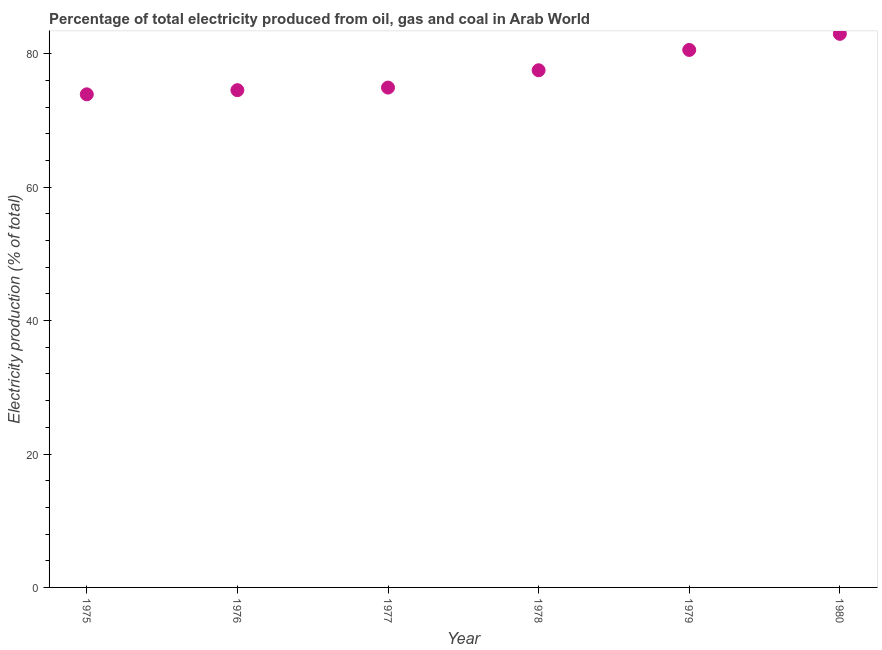What is the electricity production in 1977?
Keep it short and to the point. 74.94. Across all years, what is the maximum electricity production?
Offer a terse response. 82.99. Across all years, what is the minimum electricity production?
Your response must be concise. 73.92. In which year was the electricity production maximum?
Make the answer very short. 1980. In which year was the electricity production minimum?
Your answer should be compact. 1975. What is the sum of the electricity production?
Your answer should be very brief. 464.52. What is the difference between the electricity production in 1978 and 1980?
Offer a terse response. -5.46. What is the average electricity production per year?
Your response must be concise. 77.42. What is the median electricity production?
Make the answer very short. 76.24. Do a majority of the years between 1975 and 1979 (inclusive) have electricity production greater than 64 %?
Your answer should be compact. Yes. What is the ratio of the electricity production in 1978 to that in 1980?
Your answer should be compact. 0.93. Is the difference between the electricity production in 1975 and 1978 greater than the difference between any two years?
Your response must be concise. No. What is the difference between the highest and the second highest electricity production?
Your answer should be compact. 2.41. What is the difference between the highest and the lowest electricity production?
Your answer should be compact. 9.07. How many dotlines are there?
Keep it short and to the point. 1. How many years are there in the graph?
Ensure brevity in your answer.  6. Are the values on the major ticks of Y-axis written in scientific E-notation?
Offer a very short reply. No. Does the graph contain any zero values?
Offer a very short reply. No. What is the title of the graph?
Keep it short and to the point. Percentage of total electricity produced from oil, gas and coal in Arab World. What is the label or title of the X-axis?
Offer a terse response. Year. What is the label or title of the Y-axis?
Offer a very short reply. Electricity production (% of total). What is the Electricity production (% of total) in 1975?
Provide a short and direct response. 73.92. What is the Electricity production (% of total) in 1976?
Provide a succinct answer. 74.55. What is the Electricity production (% of total) in 1977?
Your response must be concise. 74.94. What is the Electricity production (% of total) in 1978?
Keep it short and to the point. 77.53. What is the Electricity production (% of total) in 1979?
Make the answer very short. 80.58. What is the Electricity production (% of total) in 1980?
Your answer should be very brief. 82.99. What is the difference between the Electricity production (% of total) in 1975 and 1976?
Give a very brief answer. -0.62. What is the difference between the Electricity production (% of total) in 1975 and 1977?
Give a very brief answer. -1.01. What is the difference between the Electricity production (% of total) in 1975 and 1978?
Offer a very short reply. -3.61. What is the difference between the Electricity production (% of total) in 1975 and 1979?
Provide a succinct answer. -6.66. What is the difference between the Electricity production (% of total) in 1975 and 1980?
Offer a terse response. -9.07. What is the difference between the Electricity production (% of total) in 1976 and 1977?
Offer a terse response. -0.39. What is the difference between the Electricity production (% of total) in 1976 and 1978?
Provide a succinct answer. -2.99. What is the difference between the Electricity production (% of total) in 1976 and 1979?
Ensure brevity in your answer.  -6.03. What is the difference between the Electricity production (% of total) in 1976 and 1980?
Offer a terse response. -8.44. What is the difference between the Electricity production (% of total) in 1977 and 1978?
Offer a very short reply. -2.6. What is the difference between the Electricity production (% of total) in 1977 and 1979?
Provide a short and direct response. -5.64. What is the difference between the Electricity production (% of total) in 1977 and 1980?
Provide a short and direct response. -8.05. What is the difference between the Electricity production (% of total) in 1978 and 1979?
Your response must be concise. -3.05. What is the difference between the Electricity production (% of total) in 1978 and 1980?
Your answer should be compact. -5.46. What is the difference between the Electricity production (% of total) in 1979 and 1980?
Give a very brief answer. -2.41. What is the ratio of the Electricity production (% of total) in 1975 to that in 1977?
Your response must be concise. 0.99. What is the ratio of the Electricity production (% of total) in 1975 to that in 1978?
Your response must be concise. 0.95. What is the ratio of the Electricity production (% of total) in 1975 to that in 1979?
Offer a very short reply. 0.92. What is the ratio of the Electricity production (% of total) in 1975 to that in 1980?
Provide a succinct answer. 0.89. What is the ratio of the Electricity production (% of total) in 1976 to that in 1979?
Your answer should be compact. 0.93. What is the ratio of the Electricity production (% of total) in 1976 to that in 1980?
Give a very brief answer. 0.9. What is the ratio of the Electricity production (% of total) in 1977 to that in 1978?
Keep it short and to the point. 0.97. What is the ratio of the Electricity production (% of total) in 1977 to that in 1980?
Provide a succinct answer. 0.9. What is the ratio of the Electricity production (% of total) in 1978 to that in 1980?
Give a very brief answer. 0.93. 